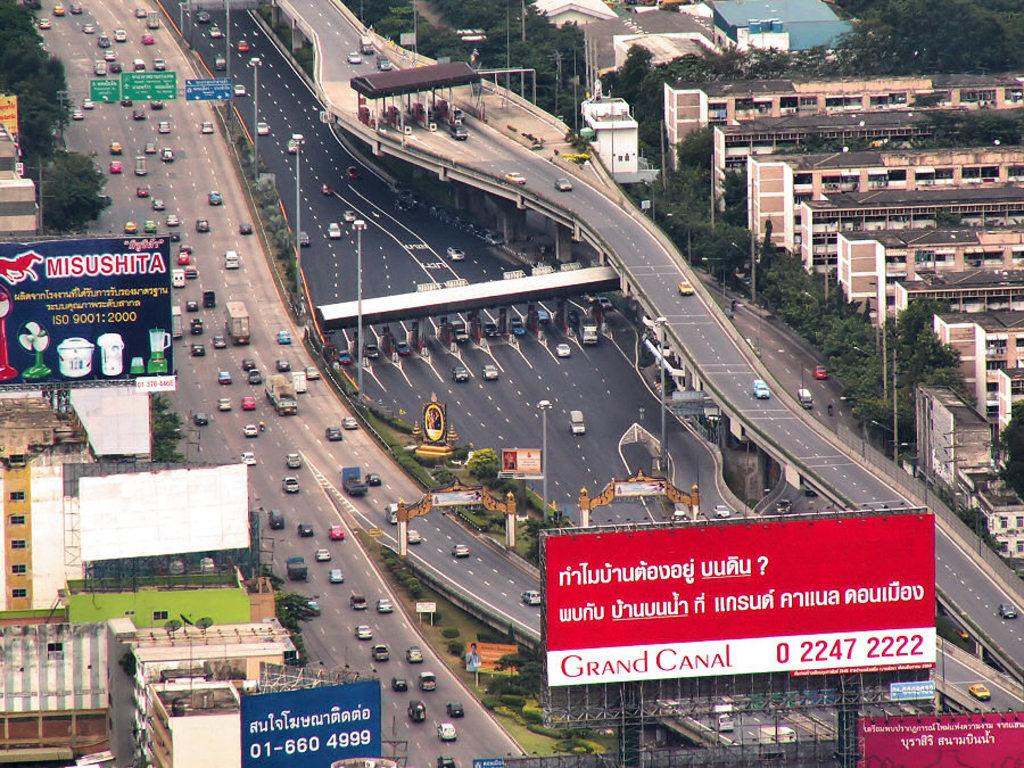Provide a one-sentence caption for the provided image. a long shot of a freeway with billboards for Grand Canal and Misushita. 